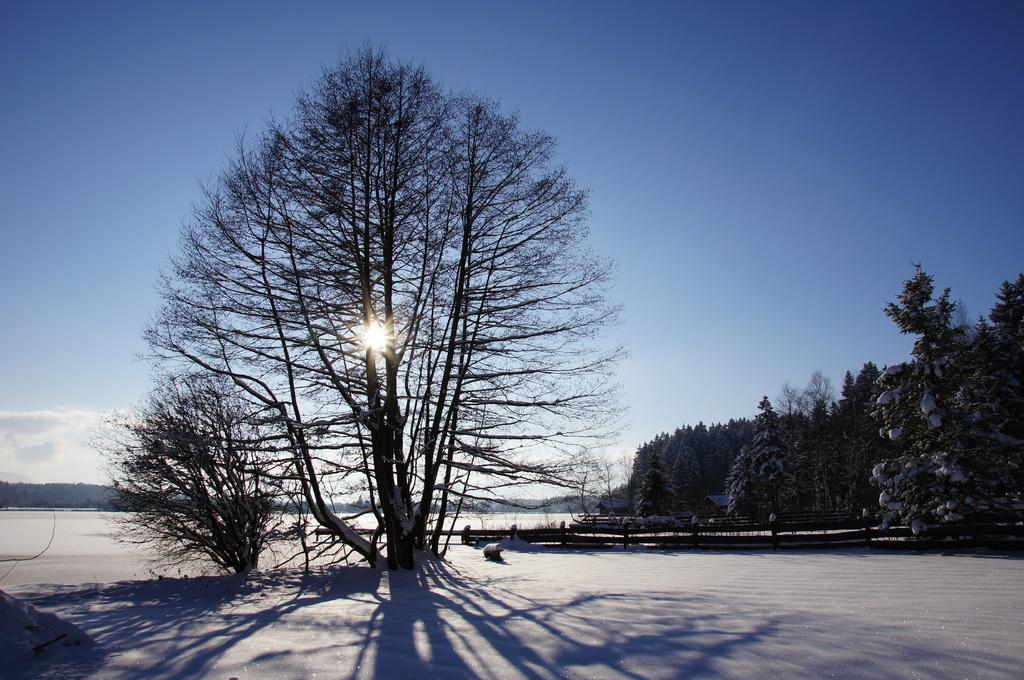What can be seen at the bottom of the image? The ground is visible in the image. What type of natural elements are present in the image? There are trees in the image. What else can be seen in the image besides the ground and trees? There are objects in the image. What is visible in the distance in the image? The sky is visible in the background of the image. How many pets are visible in the image? There are no pets present in the image. What type of building can be seen in the image? There is no building present in the image. 